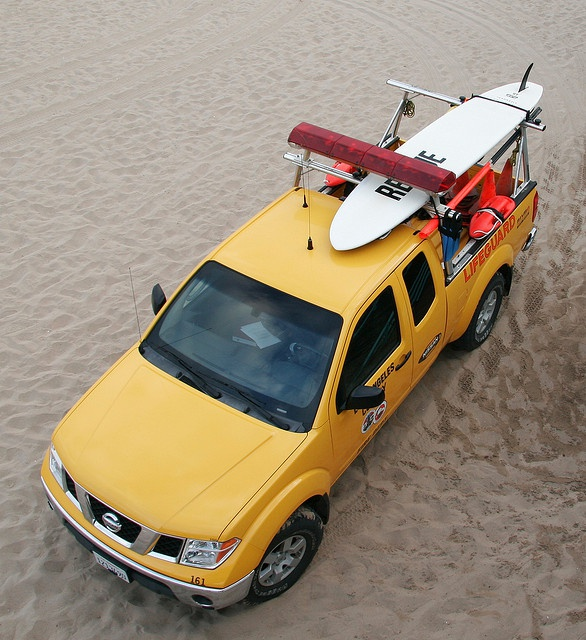Describe the objects in this image and their specific colors. I can see truck in darkgray, khaki, black, gray, and white tones and surfboard in darkgray, white, black, and gray tones in this image. 